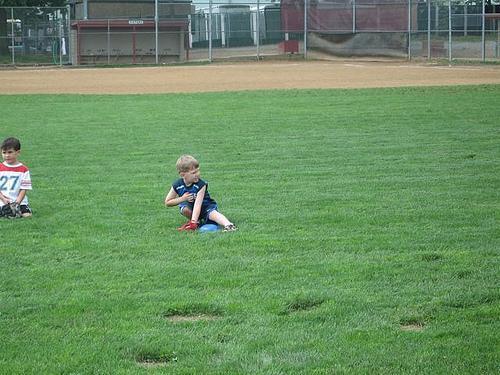How many people are there?
Give a very brief answer. 2. 